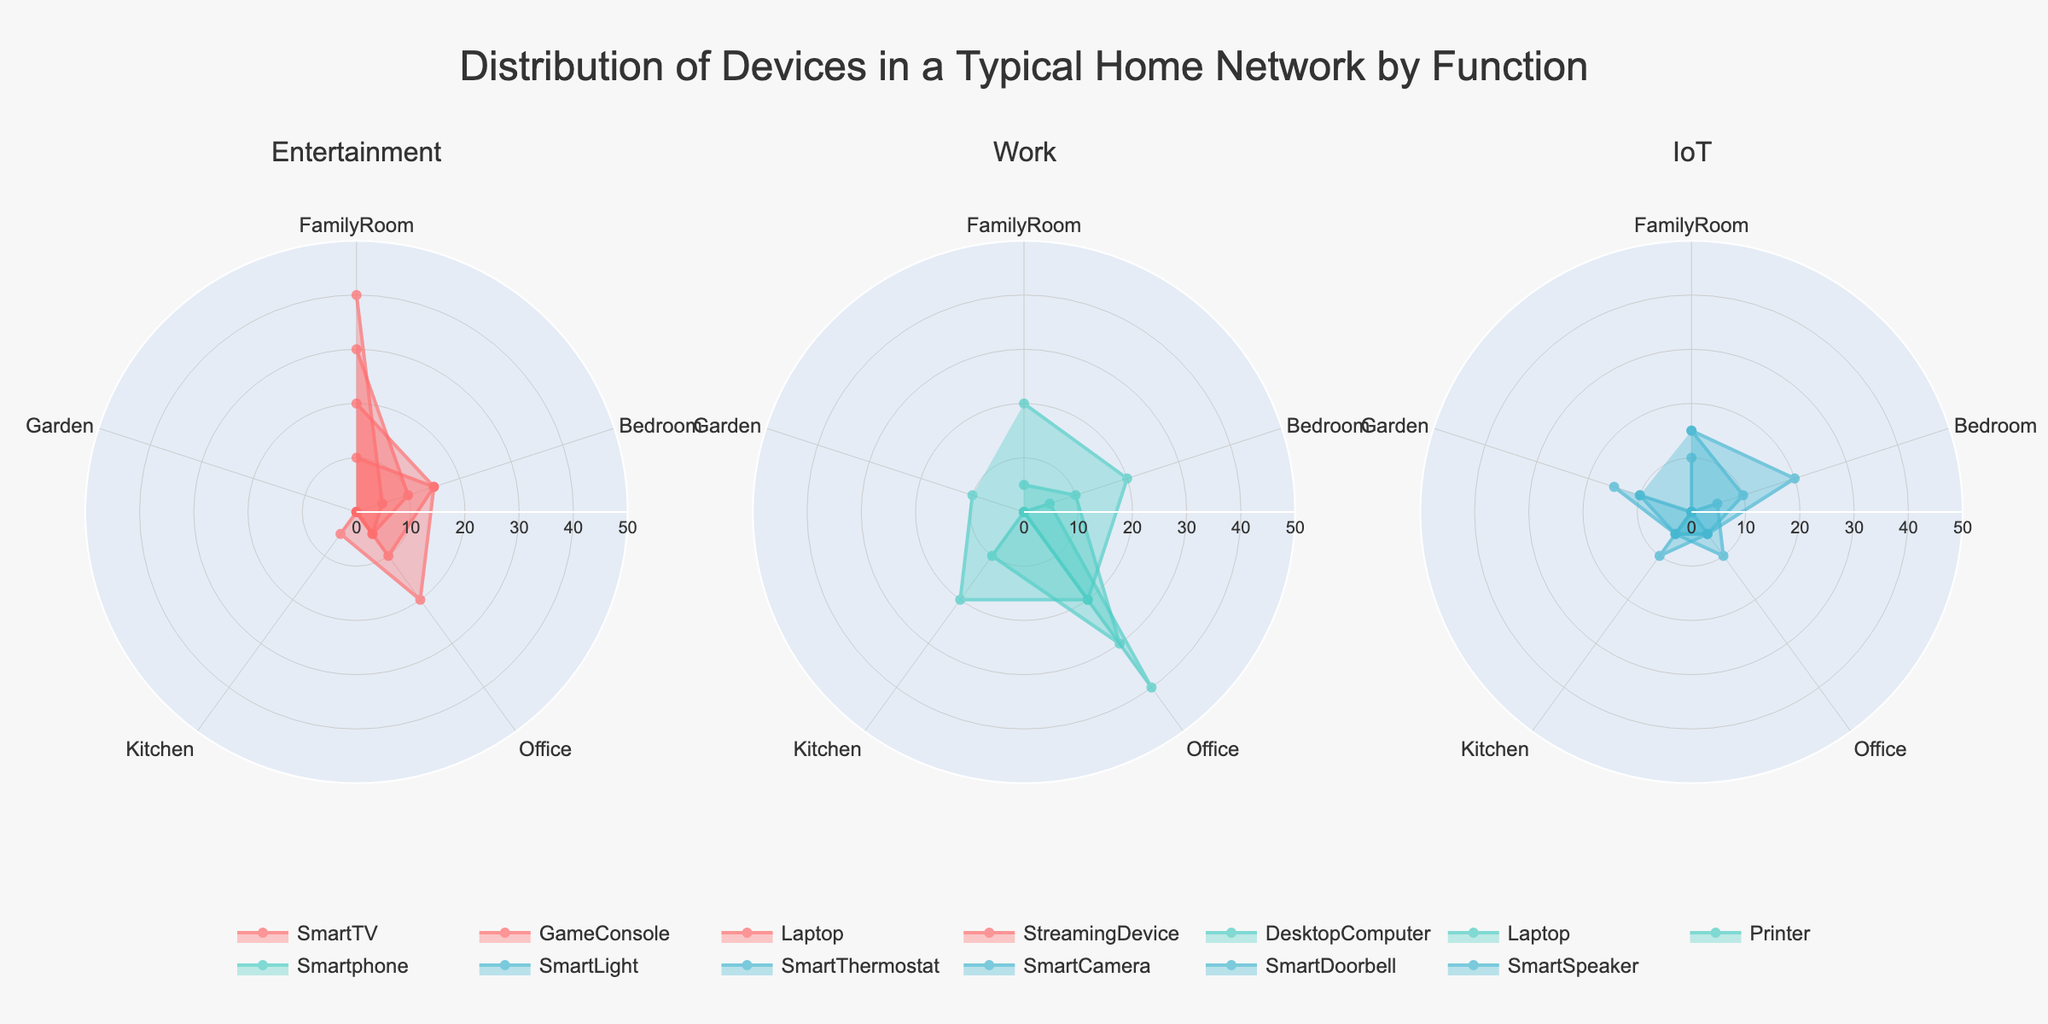How many unique devices are shown in the Entertainment function subplot? Count the distinct devices within the Entertainment function: SmartTV, GameConsole, Laptop, StreamingDevice.
Answer: 4 Which function has the highest number of devices in the FamilyRoom? Compare the FamilyRoom values for each function. Entertainment has SmartTV (30), GameConsole (20), StreamingDevice (40), and Laptop (10). Both Work and IoT functions have lower numbers.
Answer: Entertainment What is the average number of devices for Work function in the Office? Sum the Office values for Work devices: DesktopComputer (40), Laptop (30), Printer (20), Smartphone (20). Sum is 110. Divide by the number of devices (4): 110/4 = 27.5
Answer: 27.5 Which device is exclusive to the Garden according to the IoT function? Look exclusively at IoT devices in the Garden: SmartLight (10), SmartThermostat (0), SmartCamera (15), SmartDoorbell (10), SmartSpeaker (0). The unique device here is the SmartDoorbell.
Answer: SmartDoorbell What’s the total number of IoT devices placed in the Bedroom? Sum the Bedroom values for IoT devices: SmartLight (20), SmartThermostat (0), SmartCamera (5), SmartDoorbell (0), SmartSpeaker (10). Sum is 20+0+5+0+10 = 35.
Answer: 35 What function has devices in every listed room? Check which functions, if any, have values in every room (Family Room, Bedroom, Office, Kitchen, Garden). The Work function has DesktopComputer (Office), Smartphone (all locations), Laptop (all except Garden), Printer (Office).
Answer: Work Which Entertainment device has the narrowest distribution across the rooms? Review the spread of each device: SmartTV (FamilyRoom), GameConsole (FamilyRoom, Bedroom, Office), Laptop (0-25), StreamingDevice (FamilyRoom). SmartTV is only in the FamilyRoom.
Answer: SmartTV 